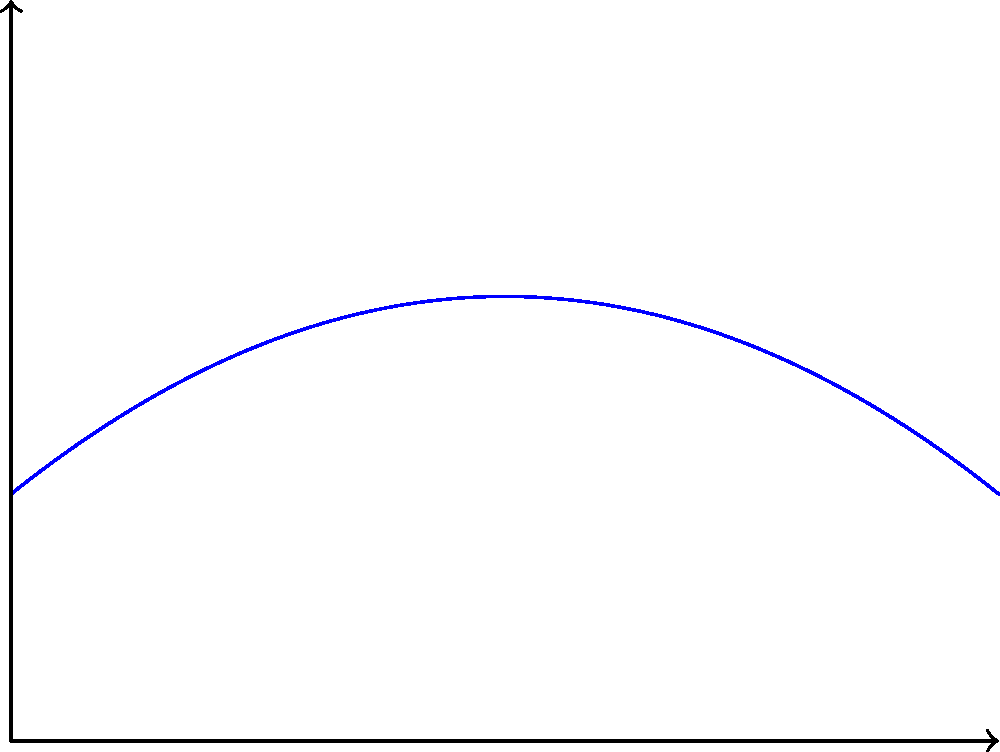At the local basketball court, you're analyzing a player's shot. The trajectory of the basketball can be modeled by the equation $y = -0.1x^2 + 0.8x + 2$, where $x$ is the horizontal distance from the release point in meters, and $y$ is the height of the ball in meters. The basket is 6 meters away from the release point and 3 meters high. What is the maximum height the ball reaches during its flight? Let's approach this step-by-step:

1) The trajectory of the ball is given by the quadratic equation:
   $y = -0.1x^2 + 0.8x + 2$

2) To find the maximum height, we need to find the vertex of this parabola. For a quadratic equation in the form $y = ax^2 + bx + c$, the x-coordinate of the vertex is given by $x = -\frac{b}{2a}$.

3) In our equation:
   $a = -0.1$
   $b = 0.8$
   $c = 2$

4) Calculating the x-coordinate of the vertex:
   $x = -\frac{0.8}{2(-0.1)} = -\frac{0.8}{-0.2} = 4$ meters

5) To find the maximum height (y-coordinate of the vertex), we substitute this x-value back into our original equation:

   $y = -0.1(4)^2 + 0.8(4) + 2$
   $y = -0.1(16) + 3.2 + 2$
   $y = -1.6 + 3.2 + 2$
   $y = 3.6$ meters

Therefore, the maximum height the ball reaches during its flight is 3.6 meters.
Answer: 3.6 meters 